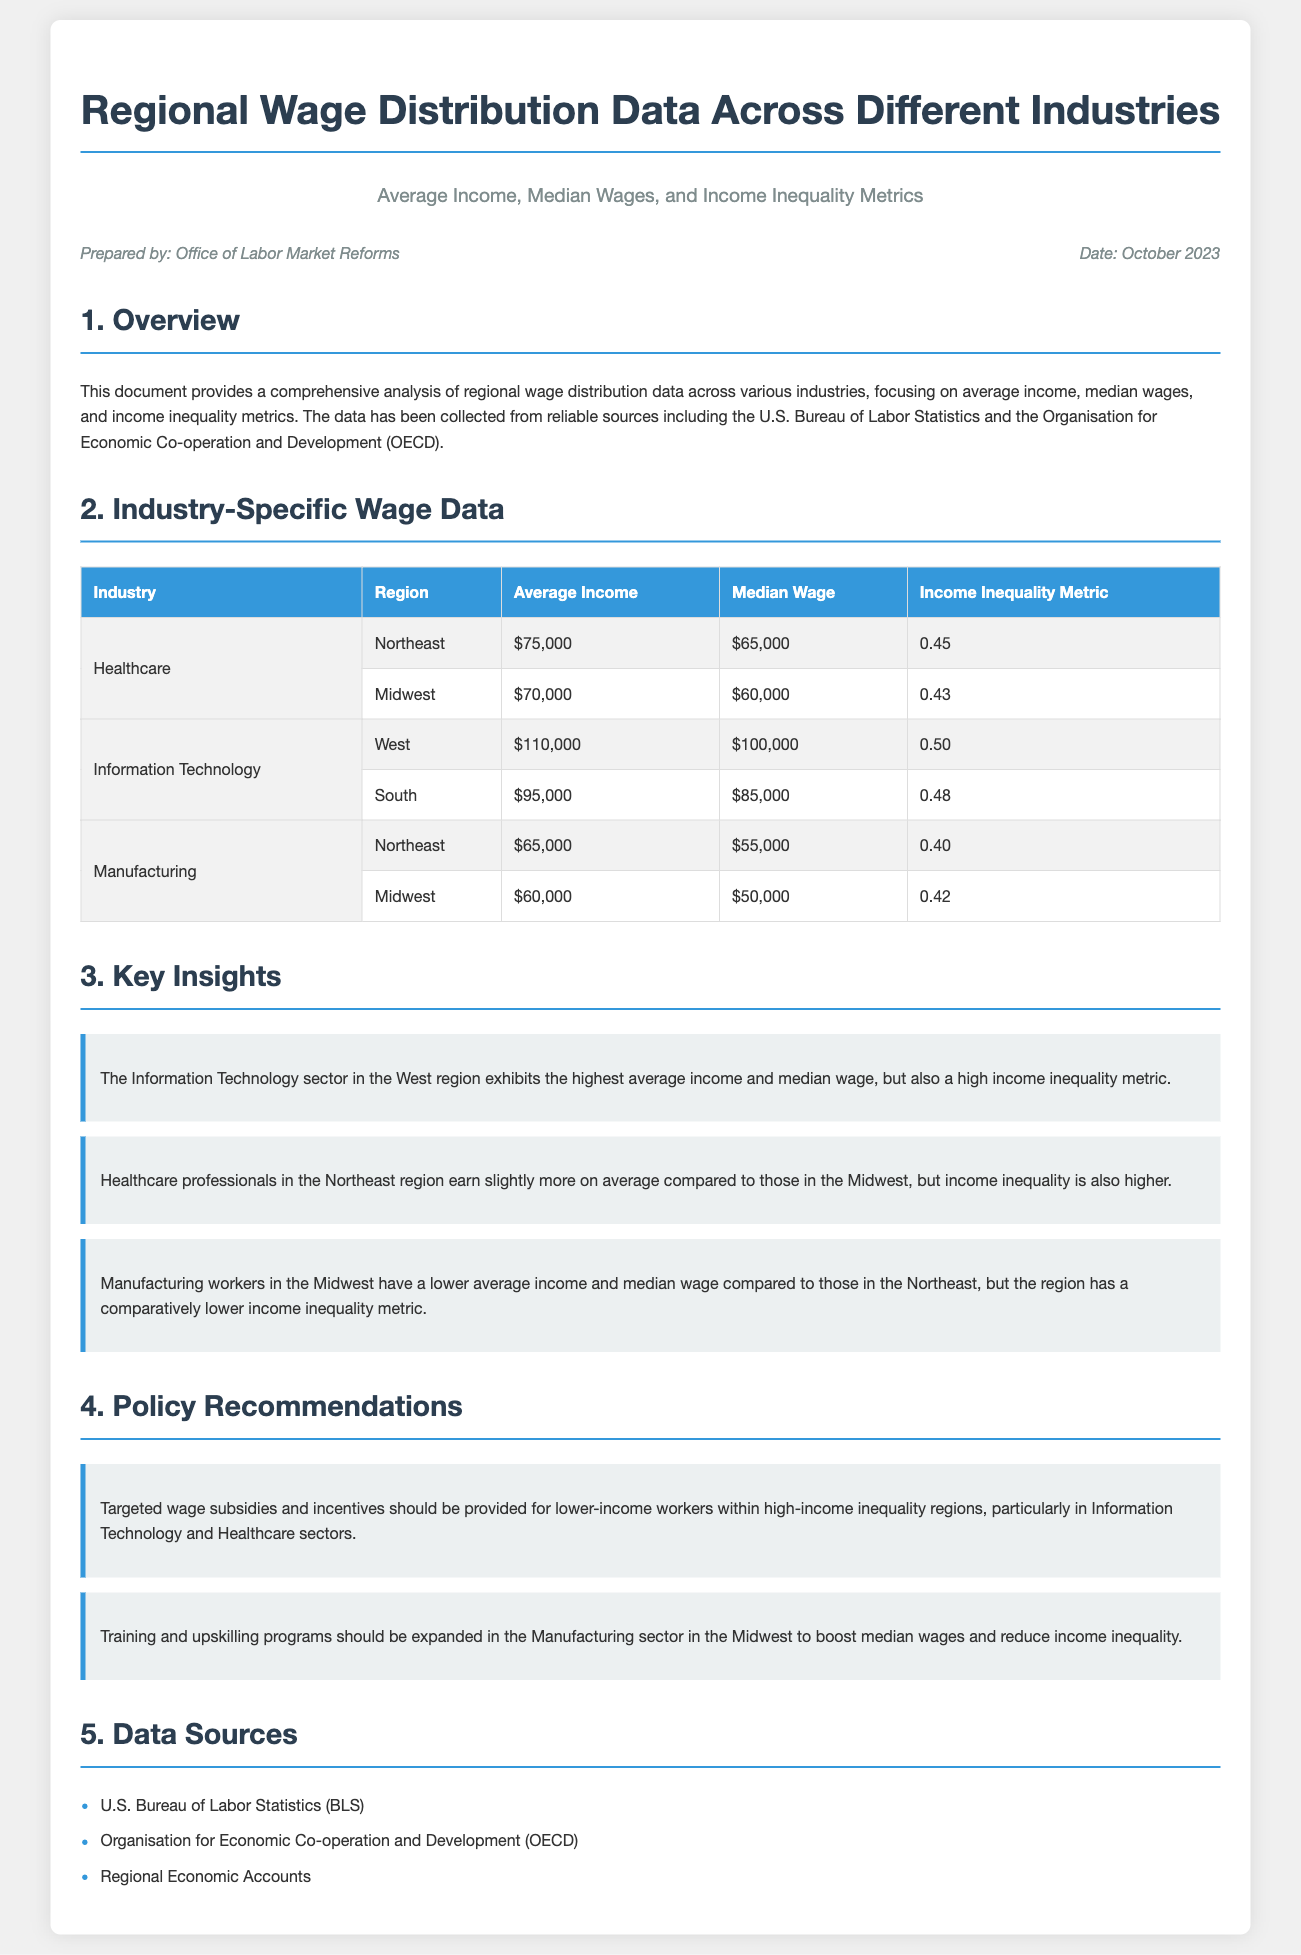What is the average income for Healthcare in the Northeast? The average income for Healthcare in the Northeast is listed in the table as $75,000.
Answer: $75,000 What is the median wage for Information Technology in the South? The median wage for Information Technology in the South can be found in the table, which is $85,000.
Answer: $85,000 Which industry has the highest income inequality metric in the West region? The industry with the highest income inequality metric in the West region is Information Technology, with a metric of 0.50.
Answer: Information Technology What policy recommendation is made for the Manufacturing sector in the Midwest? The document recommends expanding training and upskilling programs for the Manufacturing sector in the Midwest to boost wages and reduce inequality.
Answer: Expand training and upskilling programs Who prepared this document? The document states that it was prepared by the Office of Labor Market Reforms.
Answer: Office of Labor Market Reforms What is the date of the document? The date listed in the document is October 2023, as shown in the metadata section.
Answer: October 2023 